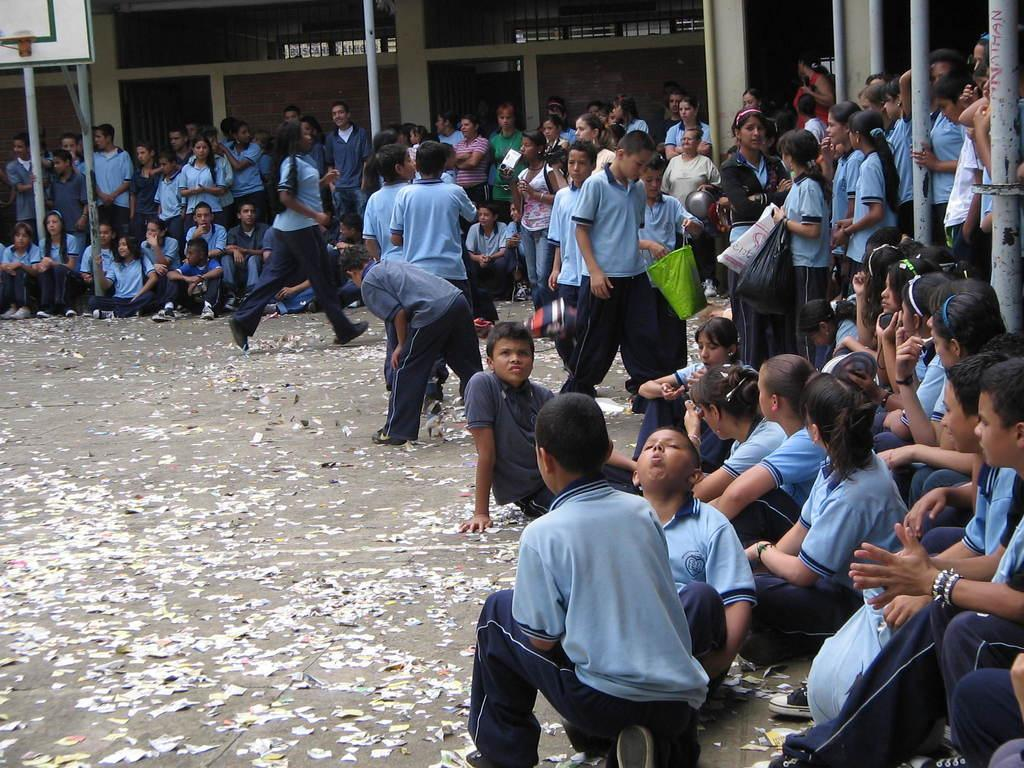What are the children in the image doing? The children in the image are sitting on the ground. What can be seen in the background of the image? There is a group of people standing, poles, and a building visible in the background of the image. What type of beam is being used by the children to play in the image? There is no beam present in the image; the children are sitting on the ground. How hot is the lumber in the image? There is no lumber present in the image, so it is not possible to determine its temperature. 